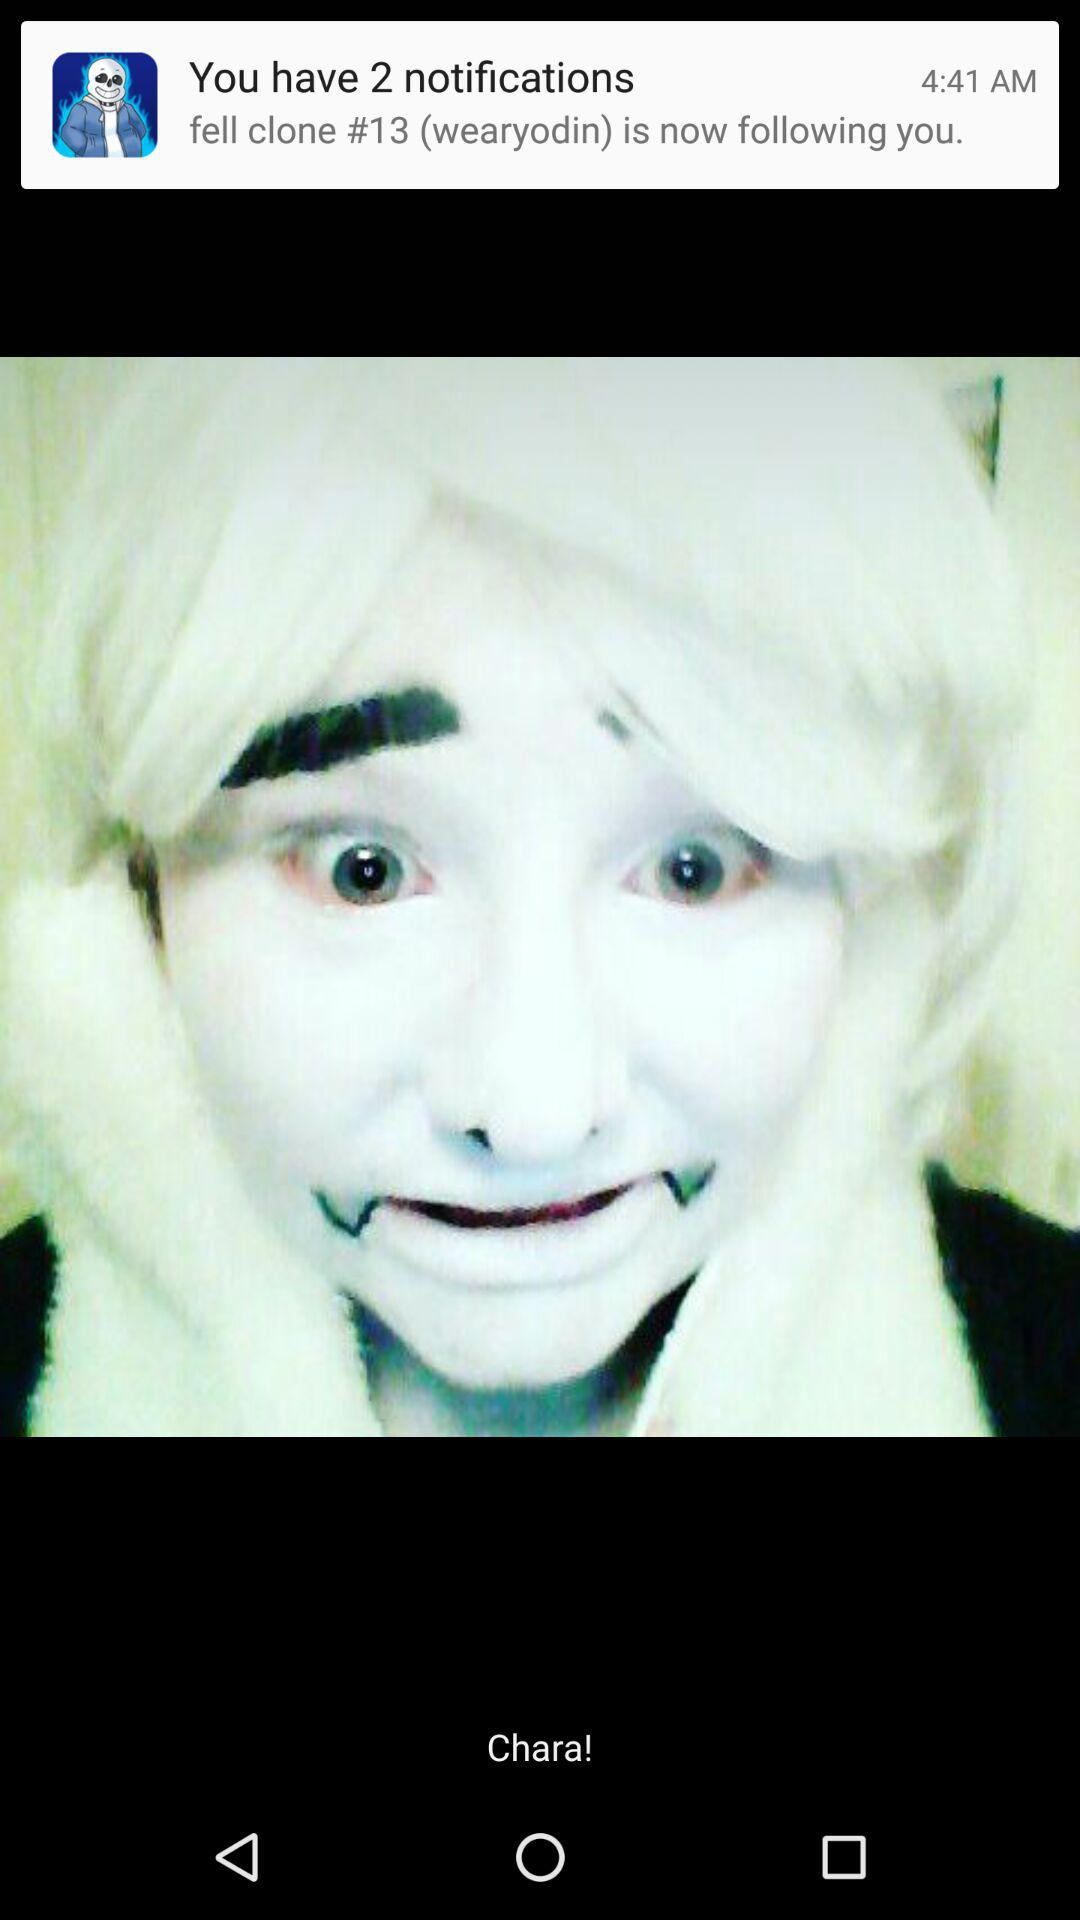Who is following me? The person who is following you is "fell clone #13 (wearyodin)". 